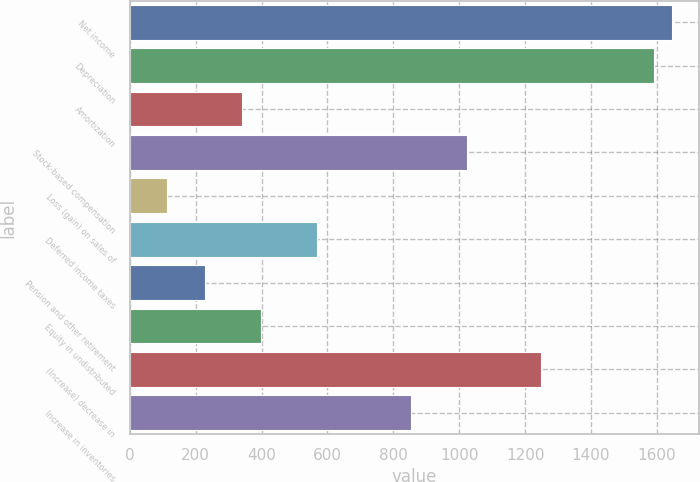<chart> <loc_0><loc_0><loc_500><loc_500><bar_chart><fcel>Net income<fcel>Depreciation<fcel>Amortization<fcel>Stock-based compensation<fcel>Loss (gain) on sales of<fcel>Deferred income taxes<fcel>Pension and other retirement<fcel>Equity in undistributed<fcel>(Increase) decrease in<fcel>Increase in inventories<nl><fcel>1646.74<fcel>1589.98<fcel>341.26<fcel>1022.38<fcel>114.22<fcel>568.3<fcel>227.74<fcel>398.02<fcel>1249.42<fcel>852.1<nl></chart> 